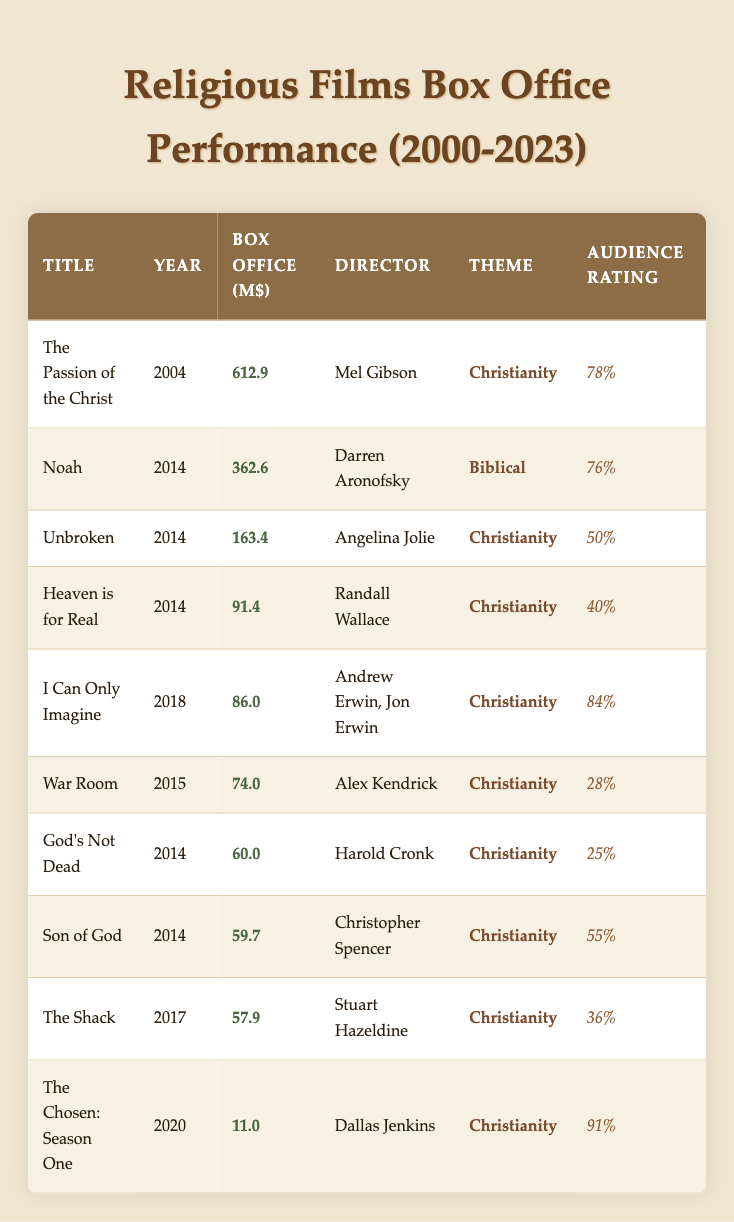What is the box office gross of "The Passion of the Christ"? The table lists "The Passion of the Christ" in the first row, where the box office gross is indicated as 612.9 million dollars.
Answer: 612.9 million dollars Who directed "Noah"? In the table, "Noah" appears in the 4th row, and the director is listed as Darren Aronofsky.
Answer: Darren Aronofsky Which film released in 2018 has the highest audience rating? By examining the rows for 2018, "I Can Only Imagine" scores 84%, which is higher than the other films from that year: "Faith Under Fire" (72%) and "Paul, Apostle of Christ" (70%).
Answer: I Can Only Imagine Is the audience rating of "God's Not Dead" greater than 30? "God's Not Dead" has an audience rating of 25%, which is less than 30%. This can be determined from the row where the film is listed.
Answer: No What is the total box office gross for all films released in 2014? Summing the box office gross for all films released in 2014: Son of God (59.7) + Noah (362.6) + God's Not Dead (60.0) + Heaven is for Real (91.4) + Unbroken (163.4) = 737.1 million dollars.
Answer: 737.1 million dollars Which film has the lowest box office gross? "Faith Under Fire" has the lowest box office gross listed, at 2.0 million dollars, among all the films in the table.
Answer: Faith Under Fire What is the average box office gross of films directed by Alex Kendrick? Alex Kendrick directed "War Room" (74.0) and "Overcomer" (11.5). The average is calculated as (74.0 + 11.5) / 2 = 42.75 million dollars.
Answer: 42.75 million dollars How many films have an audience rating of 70% or higher? The films with ratings of 70% or higher are "I Can Only Imagine" (84%), "Noah" (76%), "Unbroken" (50%), "Heaven is for Real" (40%), and "Paul, Apostle of Christ" (70%). In total, there are 5 films.
Answer: 5 films Which year saw the highest box office total across all its films? To determine the year with the highest box office gross, we should calculate the total box office for each year. In the data, 2014 has a total of 737.1 million dollars, which is higher than the totals of other years represented.
Answer: 2014 Which film has the highest audience rating, and what is the rating? The film with the highest audience rating is "The Chosen: Season One," which has a rating of 91%. This is found from the table by looking at the audience ratings listed.
Answer: The Chosen: Season One, 91% 